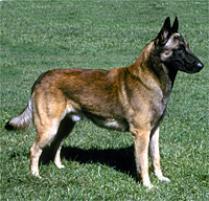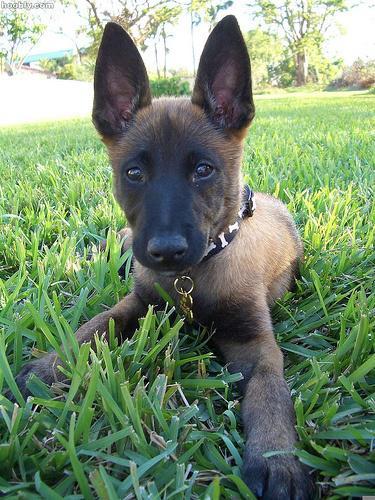The first image is the image on the left, the second image is the image on the right. For the images displayed, is the sentence "The dog in the image on the left is sitting." factually correct? Answer yes or no. No. The first image is the image on the left, the second image is the image on the right. For the images shown, is this caption "There is at least one dog sitting down" true? Answer yes or no. No. 